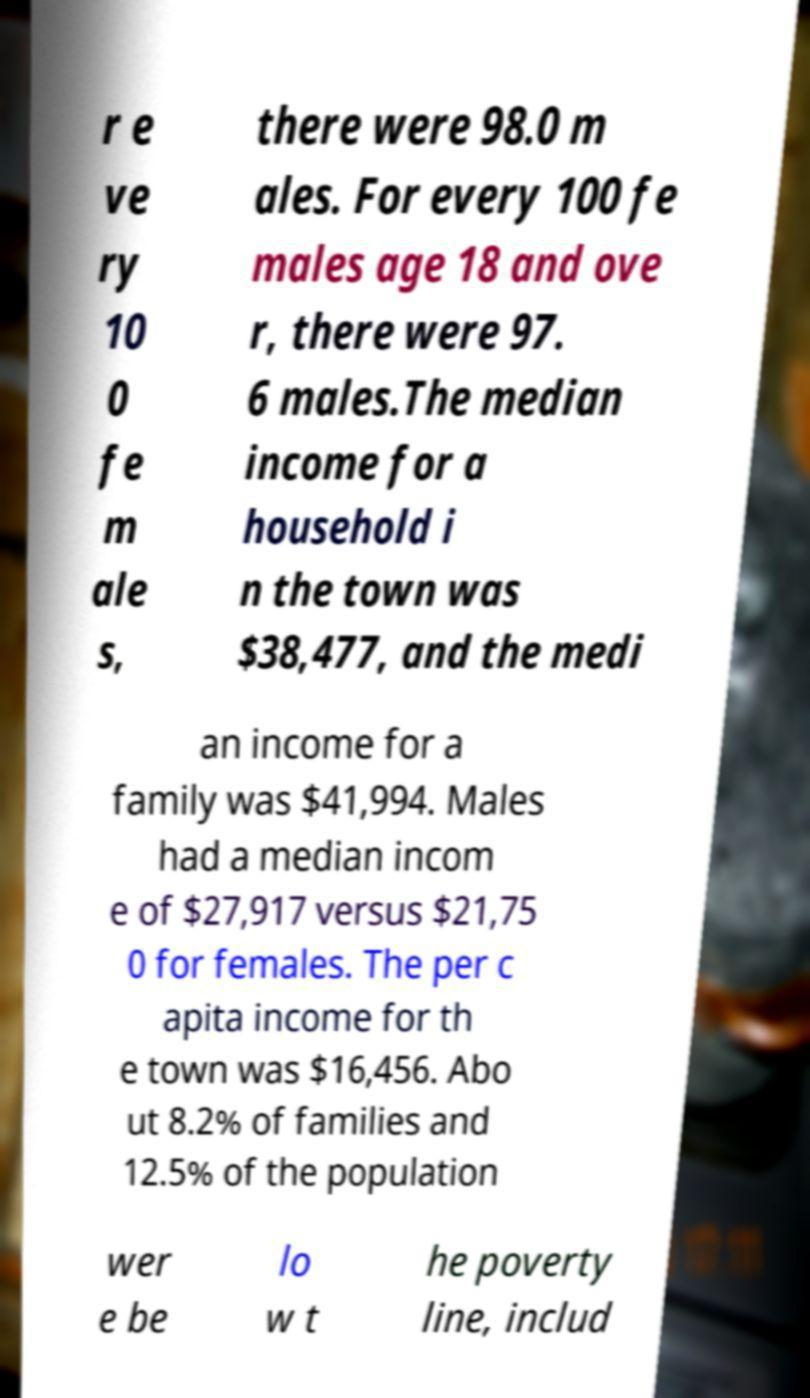Could you assist in decoding the text presented in this image and type it out clearly? r e ve ry 10 0 fe m ale s, there were 98.0 m ales. For every 100 fe males age 18 and ove r, there were 97. 6 males.The median income for a household i n the town was $38,477, and the medi an income for a family was $41,994. Males had a median incom e of $27,917 versus $21,75 0 for females. The per c apita income for th e town was $16,456. Abo ut 8.2% of families and 12.5% of the population wer e be lo w t he poverty line, includ 